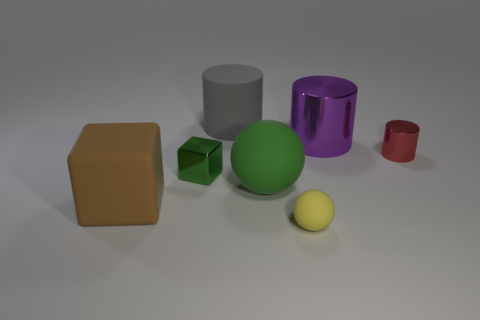What is the material of the green block?
Keep it short and to the point. Metal. Is the shape of the tiny thing in front of the large brown object the same as  the big green rubber object?
Provide a short and direct response. Yes. What is the size of the object that is the same color as the tiny metallic cube?
Provide a succinct answer. Large. Are there any green matte spheres that have the same size as the rubber block?
Ensure brevity in your answer.  Yes. There is a large matte object that is on the left side of the cube behind the large green thing; are there any rubber spheres behind it?
Provide a succinct answer. Yes. There is a tiny metallic cube; does it have the same color as the large rubber thing on the right side of the large rubber cylinder?
Offer a very short reply. Yes. What is the ball that is behind the large thing on the left side of the shiny thing to the left of the tiny rubber thing made of?
Give a very brief answer. Rubber. What shape is the small metallic object right of the purple object?
Your response must be concise. Cylinder. There is a cube that is made of the same material as the small yellow sphere; what size is it?
Provide a succinct answer. Large. How many tiny red objects are the same shape as the large purple object?
Your response must be concise. 1. 